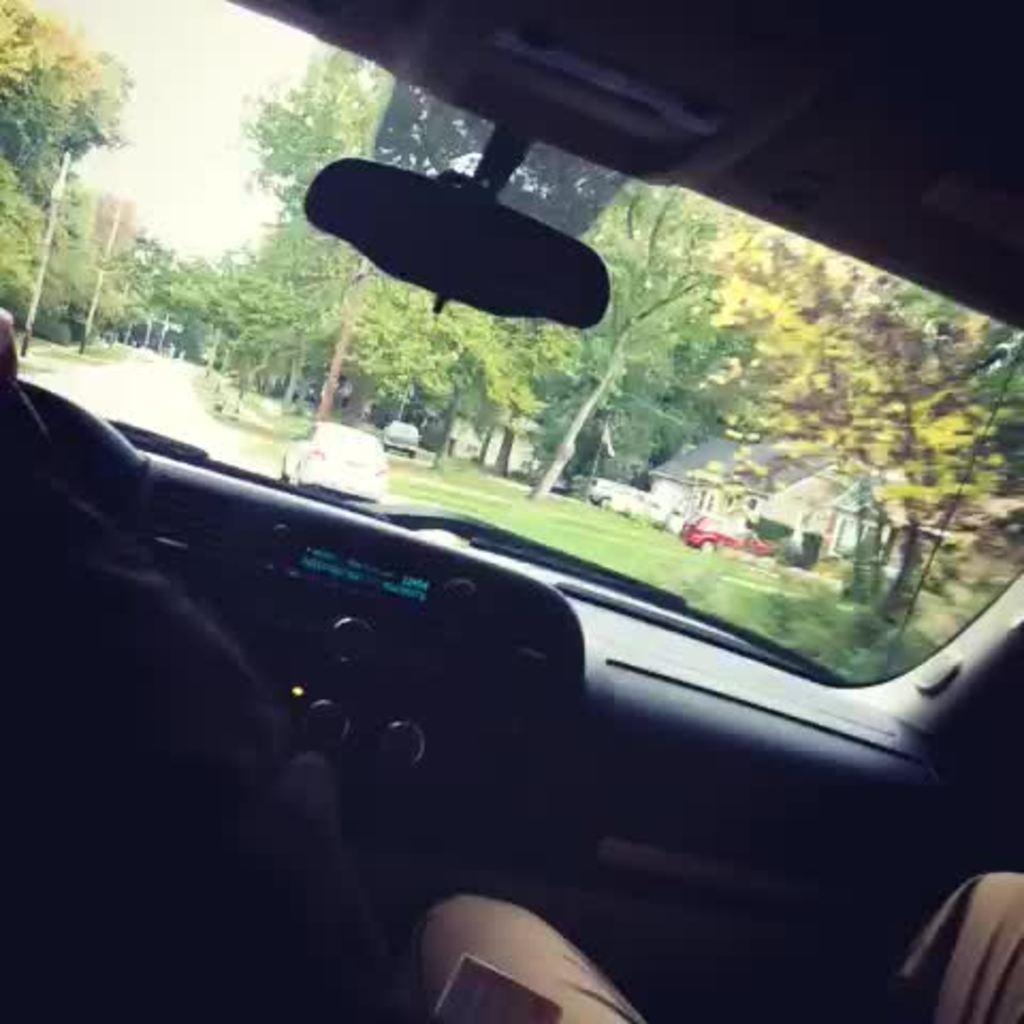Can you describe this image briefly? In this image we can see the inside view of the car that includes people, dashboard, windshield and behind that we can see trees, house and vehicles. 